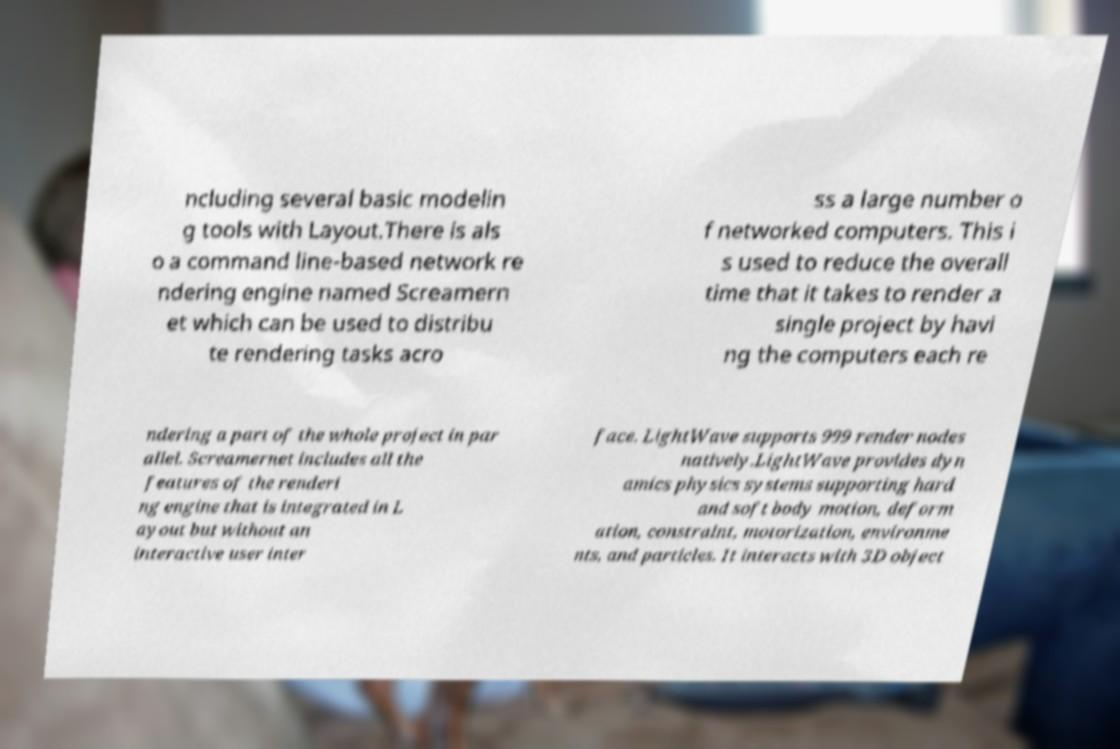Could you assist in decoding the text presented in this image and type it out clearly? ncluding several basic modelin g tools with Layout.There is als o a command line-based network re ndering engine named Screamern et which can be used to distribu te rendering tasks acro ss a large number o f networked computers. This i s used to reduce the overall time that it takes to render a single project by havi ng the computers each re ndering a part of the whole project in par allel. Screamernet includes all the features of the renderi ng engine that is integrated in L ayout but without an interactive user inter face. LightWave supports 999 render nodes natively.LightWave provides dyn amics physics systems supporting hard and soft body motion, deform ation, constraint, motorization, environme nts, and particles. It interacts with 3D object 